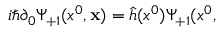Convert formula to latex. <formula><loc_0><loc_0><loc_500><loc_500>i \hbar { \partial } _ { 0 } \Psi _ { + 1 } ( x ^ { 0 } , { x } ) = \hat { h } ( x ^ { 0 } ) \Psi _ { + 1 } ( x ^ { 0 } ,</formula> 